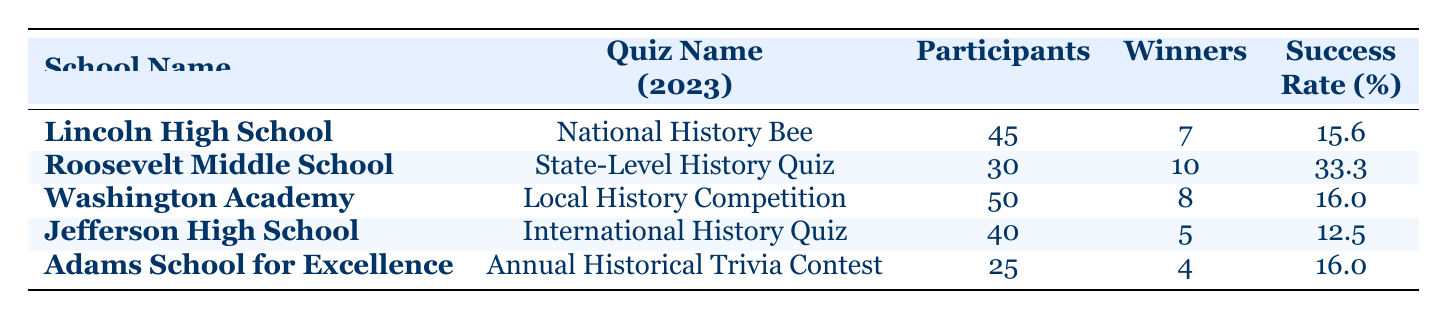What school had the highest success rate in the 2023 quizzes? Looking at the success rates listed for each school, Roosevelt Middle School has the highest success rate of 33.3% in the State-Level History Quiz.
Answer: Roosevelt Middle School How many participants did Lincoln High School have? The table shows that Lincoln High School had 45 participants in the National History Bee.
Answer: 45 Which school had the lowest number of winners, and how many did they have? Jefferson High School had the lowest number of winners, with only 5 winning participants in the International History Quiz.
Answer: Jefferson High School, 5 What is the total number of winners across all schools? To find the total number of winners, we sum the winners from each school: 7 (Lincoln) + 10 (Roosevelt) + 8 (Washington) + 5 (Jefferson) + 4 (Adams) = 34.
Answer: 34 Is the success rate of Washington Academy higher than that of Jefferson High School? Washington Academy has a success rate of 16.0%, while Jefferson High School has a success rate of 12.5%. Since 16.0% is greater than 12.5%, the answer is yes.
Answer: Yes What is the average success rate of all the schools? The success rates are 15.6, 33.3, 16.0, 12.5, and 16.0. To find the average, we sum them (15.6 + 33.3 + 16.0 + 12.5 + 16.0 = 93.4) and divide by the number of schools (5): 93.4 / 5 = 18.68.
Answer: 18.68 Which school has a success rate equal to 16.0%? Both Washington Academy and Adams School for Excellence have a success rate of 16.0%.
Answer: Washington Academy and Adams School for Excellence If we compare the total number of participants from Roosevelt Middle School and Adams School for Excellence, which school had more participants? Roosevelt Middle School had 30 participants, while Adams School for Excellence had 25 participants. Since 30 is greater than 25, Roosevelt had more participants.
Answer: Roosevelt Middle School How many more winners did Roosevelt Middle School have compared to Jefferson High School? Roosevelt had 10 winners and Jefferson had 5 winners. The difference is 10 - 5 = 5 winners.
Answer: 5 